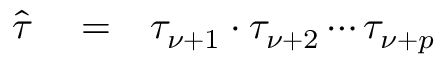Convert formula to latex. <formula><loc_0><loc_0><loc_500><loc_500>\begin{array} { r l r } { \hat { \tau } } & = } & { \tau _ { \nu + 1 } \cdot \tau _ { \nu + 2 } \cdots \tau _ { \nu + p } } \end{array}</formula> 